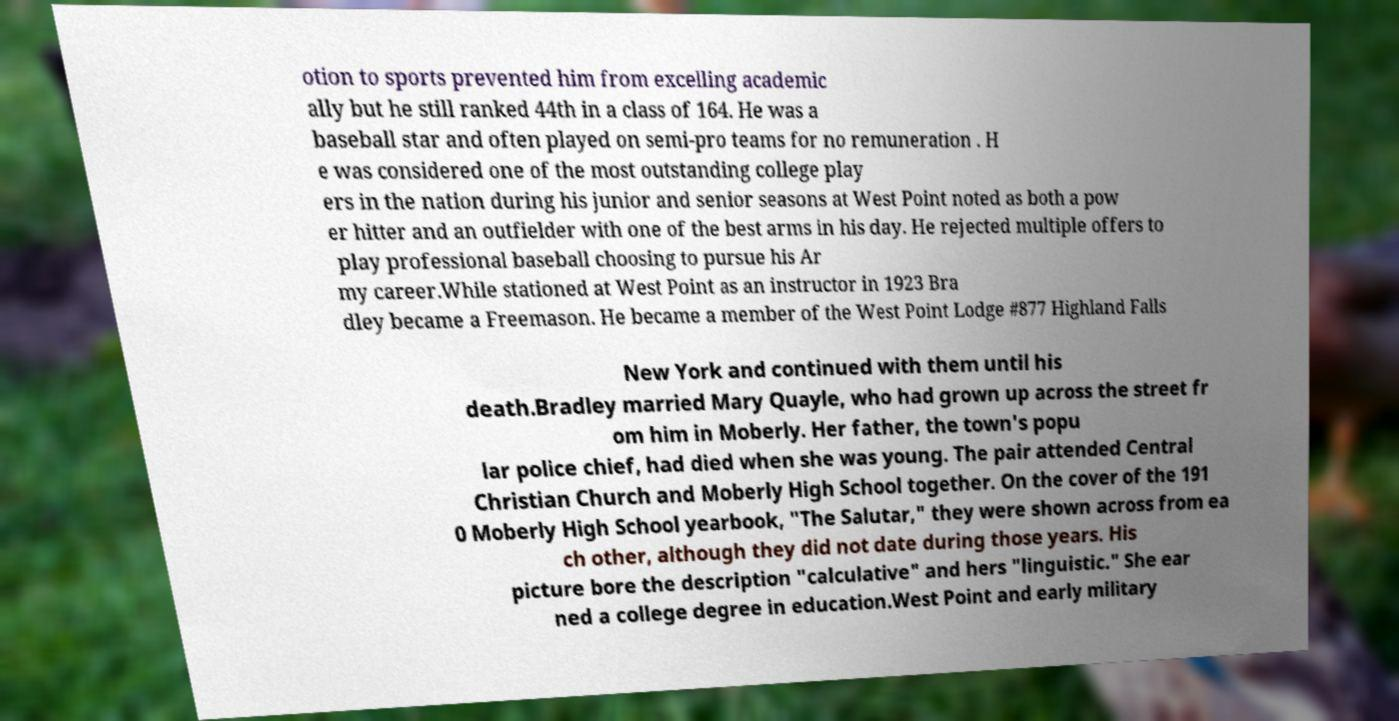Can you read and provide the text displayed in the image?This photo seems to have some interesting text. Can you extract and type it out for me? otion to sports prevented him from excelling academic ally but he still ranked 44th in a class of 164. He was a baseball star and often played on semi-pro teams for no remuneration . H e was considered one of the most outstanding college play ers in the nation during his junior and senior seasons at West Point noted as both a pow er hitter and an outfielder with one of the best arms in his day. He rejected multiple offers to play professional baseball choosing to pursue his Ar my career.While stationed at West Point as an instructor in 1923 Bra dley became a Freemason. He became a member of the West Point Lodge #877 Highland Falls New York and continued with them until his death.Bradley married Mary Quayle, who had grown up across the street fr om him in Moberly. Her father, the town's popu lar police chief, had died when she was young. The pair attended Central Christian Church and Moberly High School together. On the cover of the 191 0 Moberly High School yearbook, "The Salutar," they were shown across from ea ch other, although they did not date during those years. His picture bore the description "calculative" and hers "linguistic." She ear ned a college degree in education.West Point and early military 